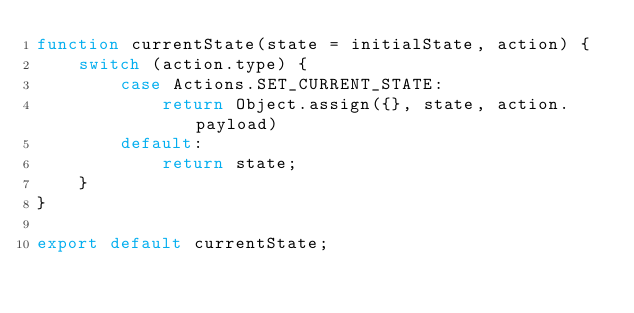<code> <loc_0><loc_0><loc_500><loc_500><_JavaScript_>function currentState(state = initialState, action) {
    switch (action.type) {
        case Actions.SET_CURRENT_STATE:
            return Object.assign({}, state, action.payload)
        default:
            return state;
    }
}

export default currentState;</code> 